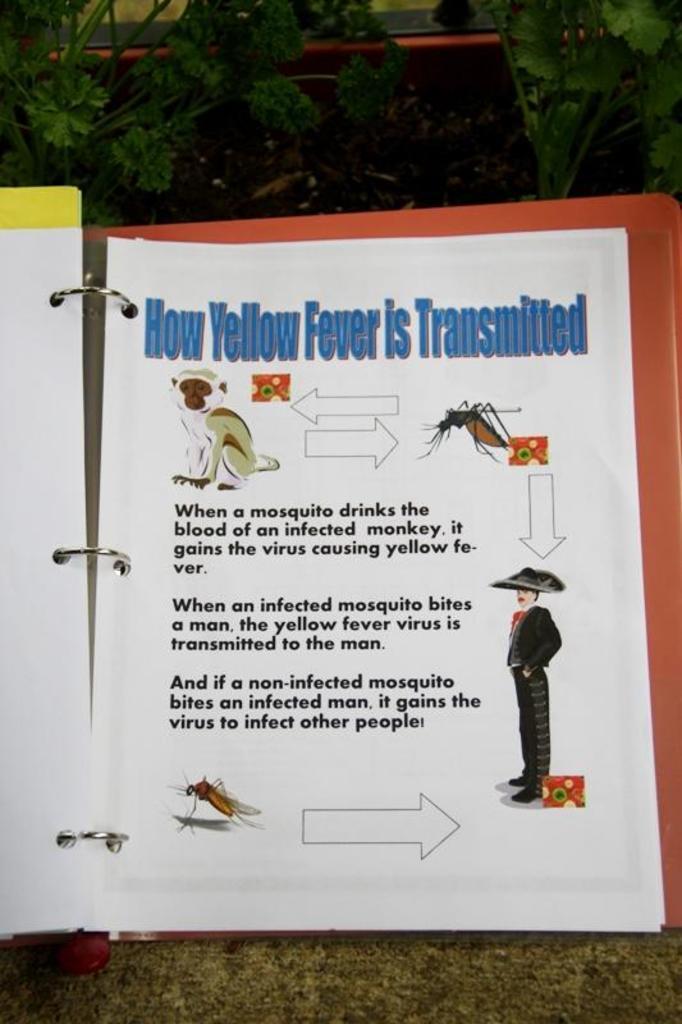Could you give a brief overview of what you see in this image? In this image there is a file. There are papers in the file. The file is open. There are pictures and text on the papers. At the top there are plants. At the bottom there is the ground. 